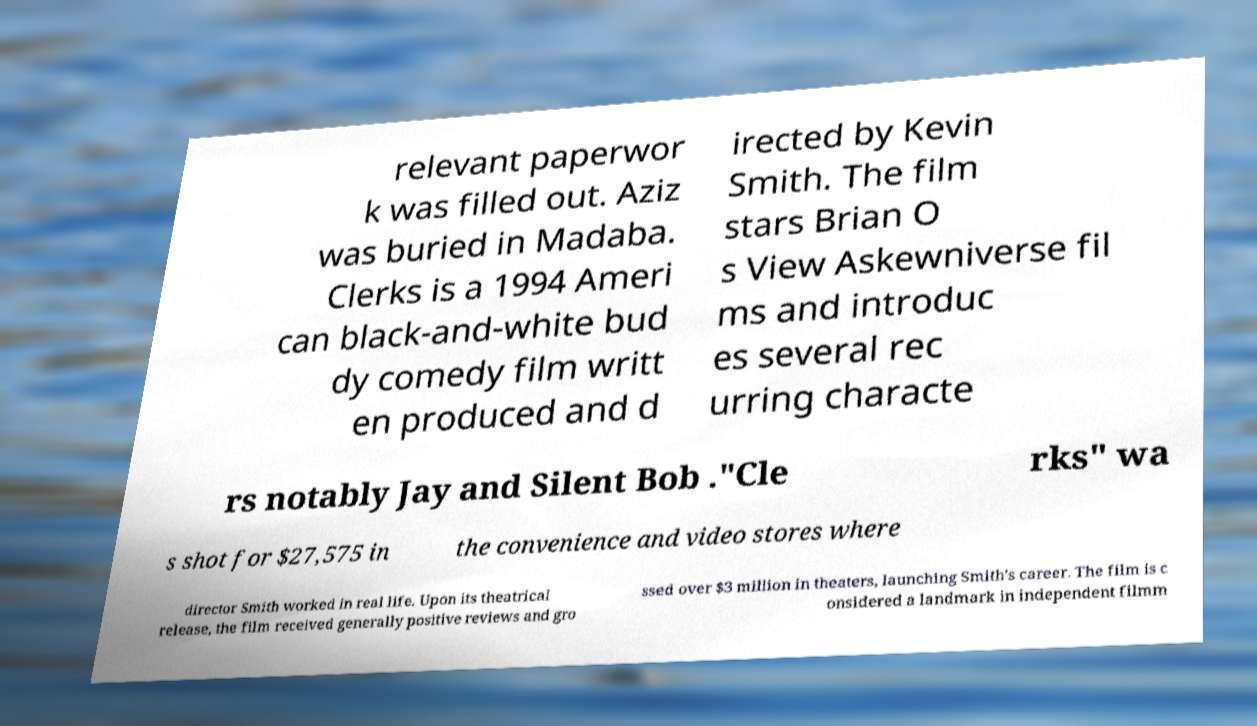I need the written content from this picture converted into text. Can you do that? relevant paperwor k was filled out. Aziz was buried in Madaba. Clerks is a 1994 Ameri can black-and-white bud dy comedy film writt en produced and d irected by Kevin Smith. The film stars Brian O s View Askewniverse fil ms and introduc es several rec urring characte rs notably Jay and Silent Bob ."Cle rks" wa s shot for $27,575 in the convenience and video stores where director Smith worked in real life. Upon its theatrical release, the film received generally positive reviews and gro ssed over $3 million in theaters, launching Smith's career. The film is c onsidered a landmark in independent filmm 